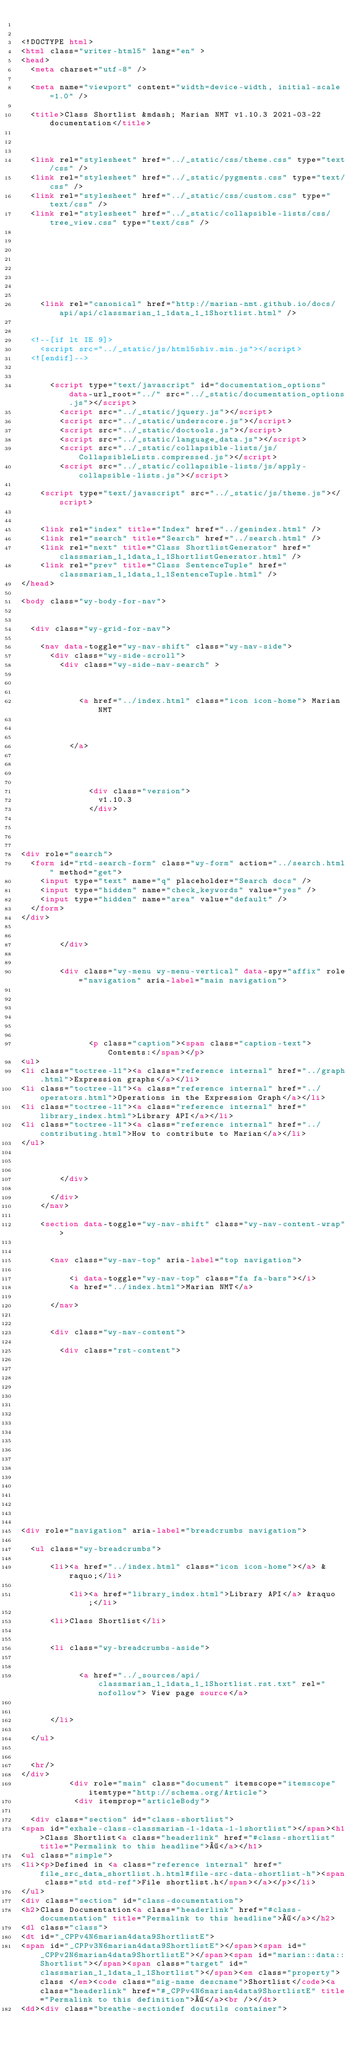Convert code to text. <code><loc_0><loc_0><loc_500><loc_500><_HTML_>

<!DOCTYPE html>
<html class="writer-html5" lang="en" >
<head>
  <meta charset="utf-8" />
  
  <meta name="viewport" content="width=device-width, initial-scale=1.0" />
  
  <title>Class Shortlist &mdash; Marian NMT v1.10.3 2021-03-22 documentation</title>
  

  
  <link rel="stylesheet" href="../_static/css/theme.css" type="text/css" />
  <link rel="stylesheet" href="../_static/pygments.css" type="text/css" />
  <link rel="stylesheet" href="../_static/css/custom.css" type="text/css" />
  <link rel="stylesheet" href="../_static/collapsible-lists/css/tree_view.css" type="text/css" />

  
  

  
  

  
    <link rel="canonical" href="http://marian-nmt.github.io/docs/api/api/classmarian_1_1data_1_1Shortlist.html" />

  
  <!--[if lt IE 9]>
    <script src="../_static/js/html5shiv.min.js"></script>
  <![endif]-->
  
    
      <script type="text/javascript" id="documentation_options" data-url_root="../" src="../_static/documentation_options.js"></script>
        <script src="../_static/jquery.js"></script>
        <script src="../_static/underscore.js"></script>
        <script src="../_static/doctools.js"></script>
        <script src="../_static/language_data.js"></script>
        <script src="../_static/collapsible-lists/js/CollapsibleLists.compressed.js"></script>
        <script src="../_static/collapsible-lists/js/apply-collapsible-lists.js"></script>
    
    <script type="text/javascript" src="../_static/js/theme.js"></script>

    
    <link rel="index" title="Index" href="../genindex.html" />
    <link rel="search" title="Search" href="../search.html" />
    <link rel="next" title="Class ShortlistGenerator" href="classmarian_1_1data_1_1ShortlistGenerator.html" />
    <link rel="prev" title="Class SentenceTuple" href="classmarian_1_1data_1_1SentenceTuple.html" /> 
</head>

<body class="wy-body-for-nav">

   
  <div class="wy-grid-for-nav">
    
    <nav data-toggle="wy-nav-shift" class="wy-nav-side">
      <div class="wy-side-scroll">
        <div class="wy-side-nav-search" >
          

          
            <a href="../index.html" class="icon icon-home"> Marian NMT
          

          
          </a>

          
            
            
              <div class="version">
                v1.10.3
              </div>
            
          

          
<div role="search">
  <form id="rtd-search-form" class="wy-form" action="../search.html" method="get">
    <input type="text" name="q" placeholder="Search docs" />
    <input type="hidden" name="check_keywords" value="yes" />
    <input type="hidden" name="area" value="default" />
  </form>
</div>

          
        </div>

        
        <div class="wy-menu wy-menu-vertical" data-spy="affix" role="navigation" aria-label="main navigation">
          
            
            
              
            
            
              <p class="caption"><span class="caption-text">Contents:</span></p>
<ul>
<li class="toctree-l1"><a class="reference internal" href="../graph.html">Expression graphs</a></li>
<li class="toctree-l1"><a class="reference internal" href="../operators.html">Operations in the Expression Graph</a></li>
<li class="toctree-l1"><a class="reference internal" href="library_index.html">Library API</a></li>
<li class="toctree-l1"><a class="reference internal" href="../contributing.html">How to contribute to Marian</a></li>
</ul>

            
          
        </div>
        
      </div>
    </nav>

    <section data-toggle="wy-nav-shift" class="wy-nav-content-wrap">

      
      <nav class="wy-nav-top" aria-label="top navigation">
        
          <i data-toggle="wy-nav-top" class="fa fa-bars"></i>
          <a href="../index.html">Marian NMT</a>
        
      </nav>


      <div class="wy-nav-content">
        
        <div class="rst-content">
        
          

















<div role="navigation" aria-label="breadcrumbs navigation">

  <ul class="wy-breadcrumbs">
    
      <li><a href="../index.html" class="icon icon-home"></a> &raquo;</li>
        
          <li><a href="library_index.html">Library API</a> &raquo;</li>
        
      <li>Class Shortlist</li>
    
    
      <li class="wy-breadcrumbs-aside">
        
          
            <a href="../_sources/api/classmarian_1_1data_1_1Shortlist.rst.txt" rel="nofollow"> View page source</a>
          
        
      </li>
    
  </ul>

  
  <hr/>
</div>
          <div role="main" class="document" itemscope="itemscope" itemtype="http://schema.org/Article">
           <div itemprop="articleBody">
            
  <div class="section" id="class-shortlist">
<span id="exhale-class-classmarian-1-1data-1-1shortlist"></span><h1>Class Shortlist<a class="headerlink" href="#class-shortlist" title="Permalink to this headline">¶</a></h1>
<ul class="simple">
<li><p>Defined in <a class="reference internal" href="file_src_data_shortlist.h.html#file-src-data-shortlist-h"><span class="std std-ref">File shortlist.h</span></a></p></li>
</ul>
<div class="section" id="class-documentation">
<h2>Class Documentation<a class="headerlink" href="#class-documentation" title="Permalink to this headline">¶</a></h2>
<dl class="class">
<dt id="_CPPv4N6marian4data9ShortlistE">
<span id="_CPPv3N6marian4data9ShortlistE"></span><span id="_CPPv2N6marian4data9ShortlistE"></span><span id="marian::data::Shortlist"></span><span class="target" id="classmarian_1_1data_1_1Shortlist"></span><em class="property">class </em><code class="sig-name descname">Shortlist</code><a class="headerlink" href="#_CPPv4N6marian4data9ShortlistE" title="Permalink to this definition">¶</a><br /></dt>
<dd><div class="breathe-sectiondef docutils container"></code> 